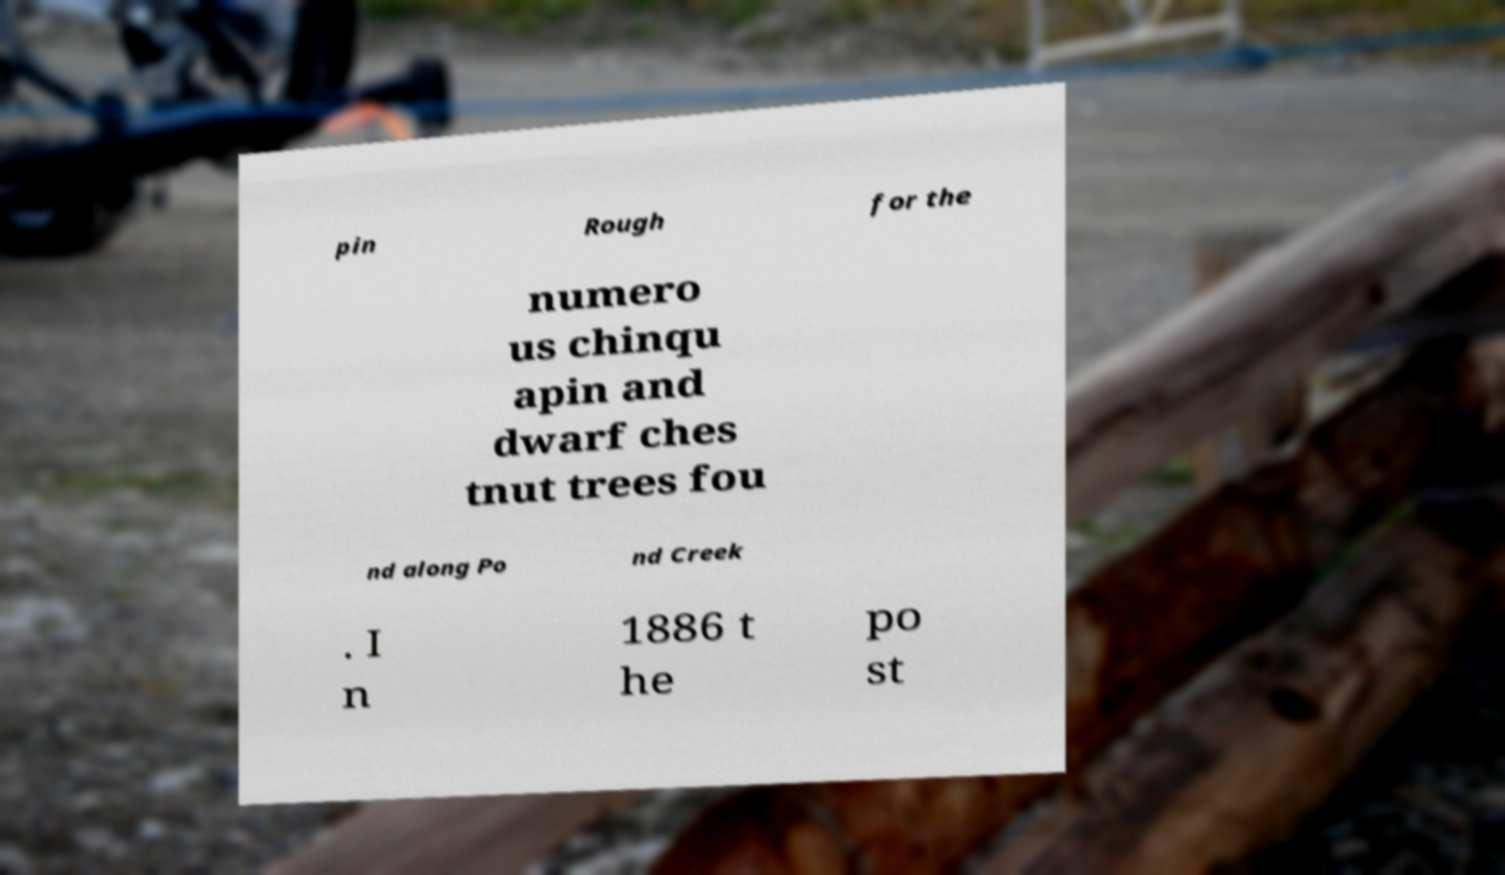There's text embedded in this image that I need extracted. Can you transcribe it verbatim? pin Rough for the numero us chinqu apin and dwarf ches tnut trees fou nd along Po nd Creek . I n 1886 t he po st 